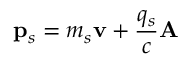<formula> <loc_0><loc_0><loc_500><loc_500>p _ { s } = m _ { s } v + \frac { q _ { s } } { c } A</formula> 